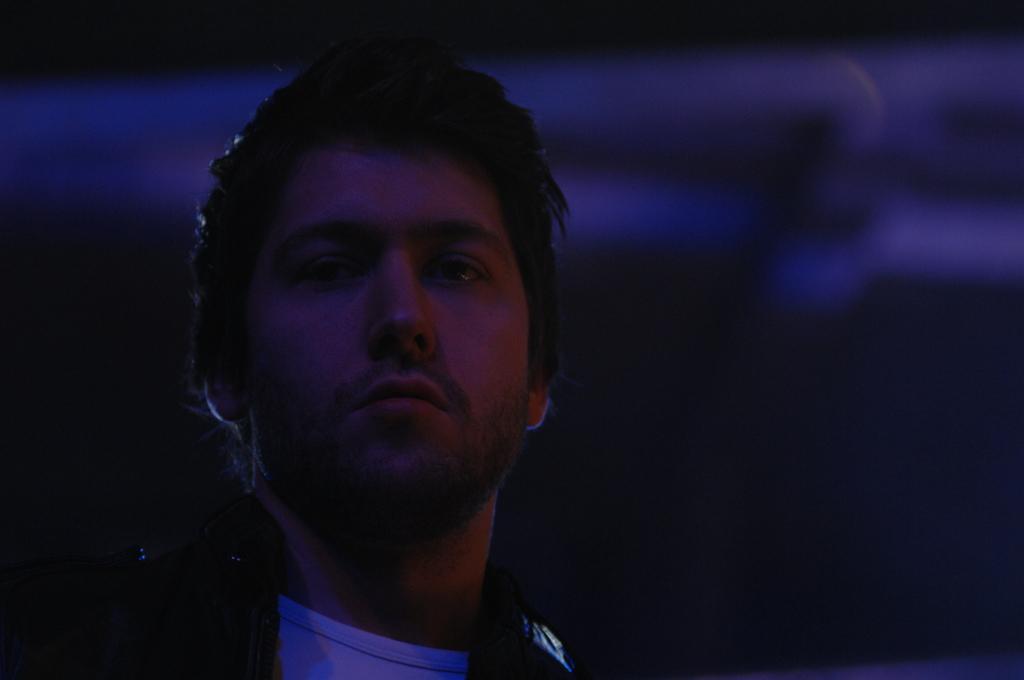Describe this image in one or two sentences. This is a zoomed in picture. In the foreground there is a man. The background of the image is very blurry. 